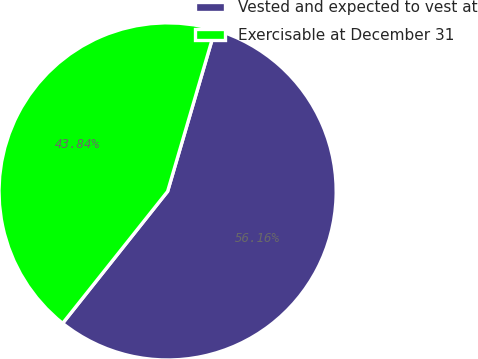Convert chart to OTSL. <chart><loc_0><loc_0><loc_500><loc_500><pie_chart><fcel>Vested and expected to vest at<fcel>Exercisable at December 31<nl><fcel>56.16%<fcel>43.84%<nl></chart> 